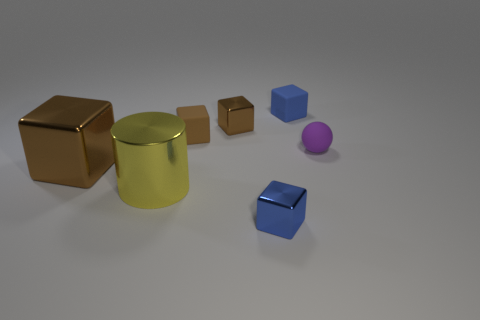Add 1 big red cylinders. How many objects exist? 8 Subtract all blue metallic blocks. How many blocks are left? 4 Subtract all tiny shiny objects. Subtract all tiny brown things. How many objects are left? 3 Add 1 big yellow things. How many big yellow things are left? 2 Add 1 small brown metal blocks. How many small brown metal blocks exist? 2 Subtract all blue blocks. How many blocks are left? 3 Subtract 0 red cylinders. How many objects are left? 7 Subtract all cylinders. How many objects are left? 6 Subtract 5 cubes. How many cubes are left? 0 Subtract all yellow blocks. Subtract all gray cylinders. How many blocks are left? 5 